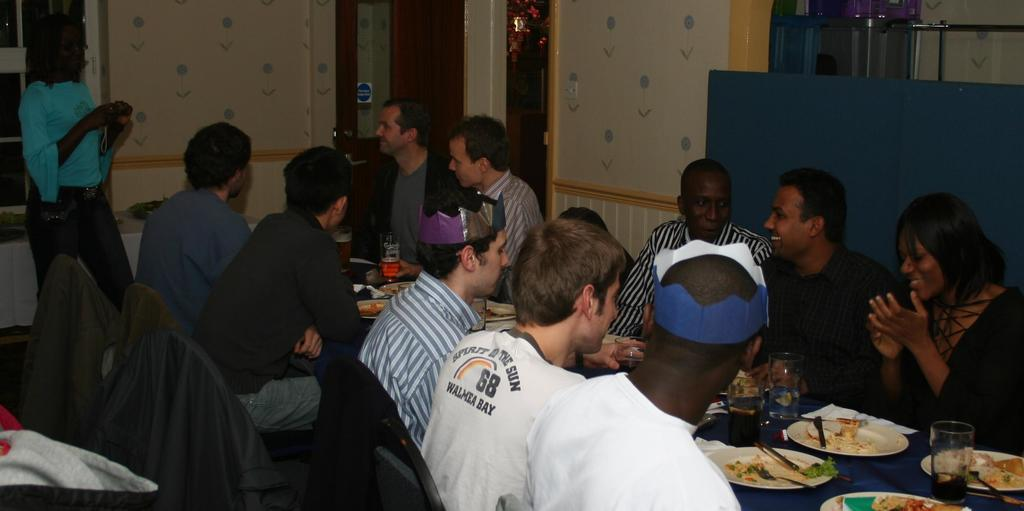<image>
Create a compact narrative representing the image presented. A man sits at a table with many others while wearing a shirt that says Walmea Bay on the back 